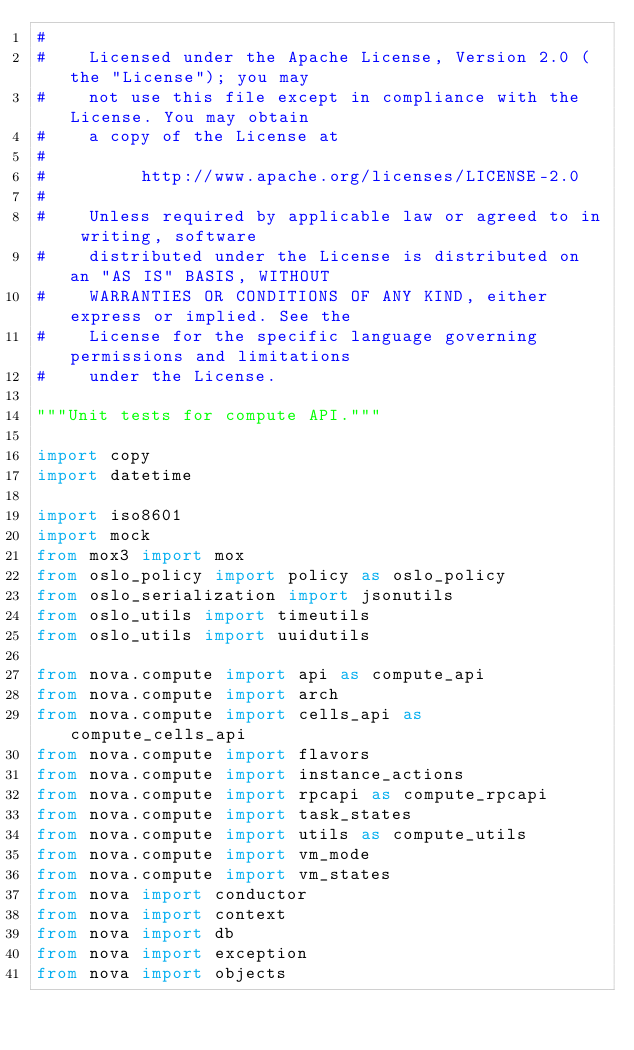<code> <loc_0><loc_0><loc_500><loc_500><_Python_>#
#    Licensed under the Apache License, Version 2.0 (the "License"); you may
#    not use this file except in compliance with the License. You may obtain
#    a copy of the License at
#
#         http://www.apache.org/licenses/LICENSE-2.0
#
#    Unless required by applicable law or agreed to in writing, software
#    distributed under the License is distributed on an "AS IS" BASIS, WITHOUT
#    WARRANTIES OR CONDITIONS OF ANY KIND, either express or implied. See the
#    License for the specific language governing permissions and limitations
#    under the License.

"""Unit tests for compute API."""

import copy
import datetime

import iso8601
import mock
from mox3 import mox
from oslo_policy import policy as oslo_policy
from oslo_serialization import jsonutils
from oslo_utils import timeutils
from oslo_utils import uuidutils

from nova.compute import api as compute_api
from nova.compute import arch
from nova.compute import cells_api as compute_cells_api
from nova.compute import flavors
from nova.compute import instance_actions
from nova.compute import rpcapi as compute_rpcapi
from nova.compute import task_states
from nova.compute import utils as compute_utils
from nova.compute import vm_mode
from nova.compute import vm_states
from nova import conductor
from nova import context
from nova import db
from nova import exception
from nova import objects</code> 